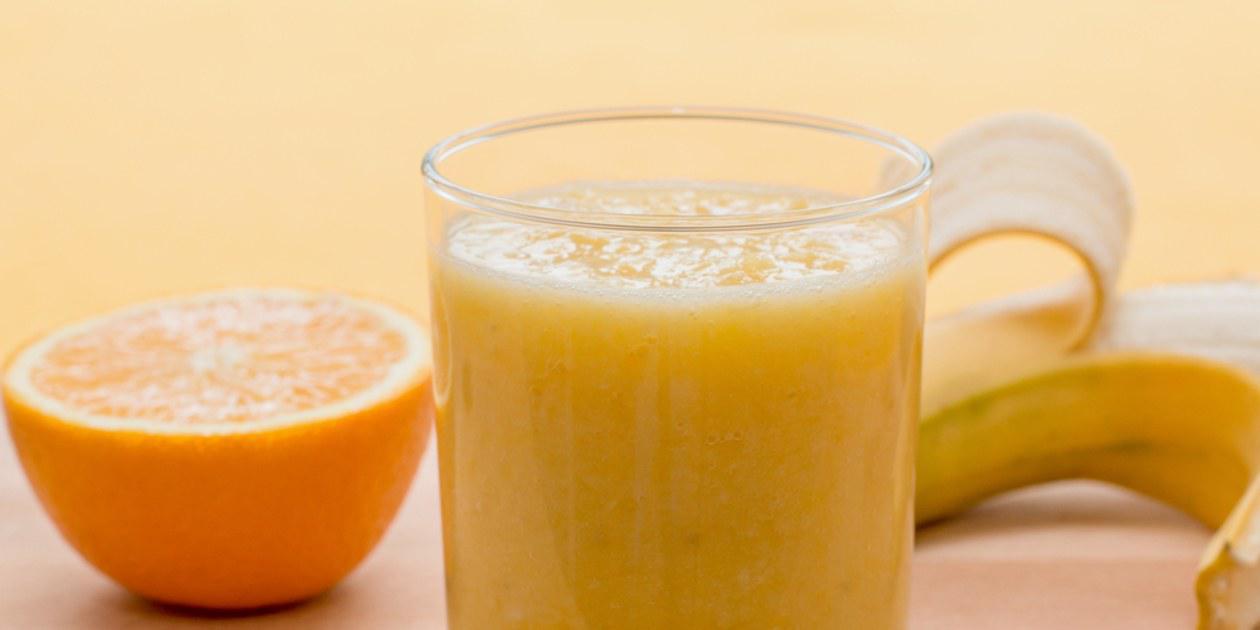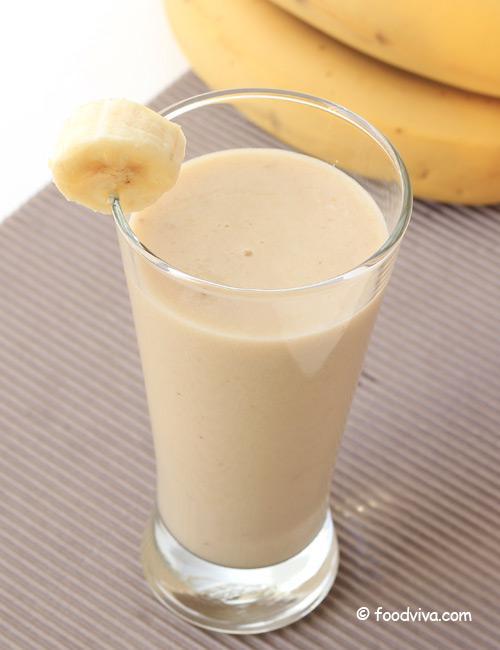The first image is the image on the left, the second image is the image on the right. For the images displayed, is the sentence "All images include unpeeled bananas, and one image includes a brown drink garnished with a slice of banana, while the other image includes a glass with something bright yellow sticking out of the top." factually correct? Answer yes or no. No. The first image is the image on the left, the second image is the image on the right. Analyze the images presented: Is the assertion "there is a glass with at least one straw in it" valid? Answer yes or no. No. 